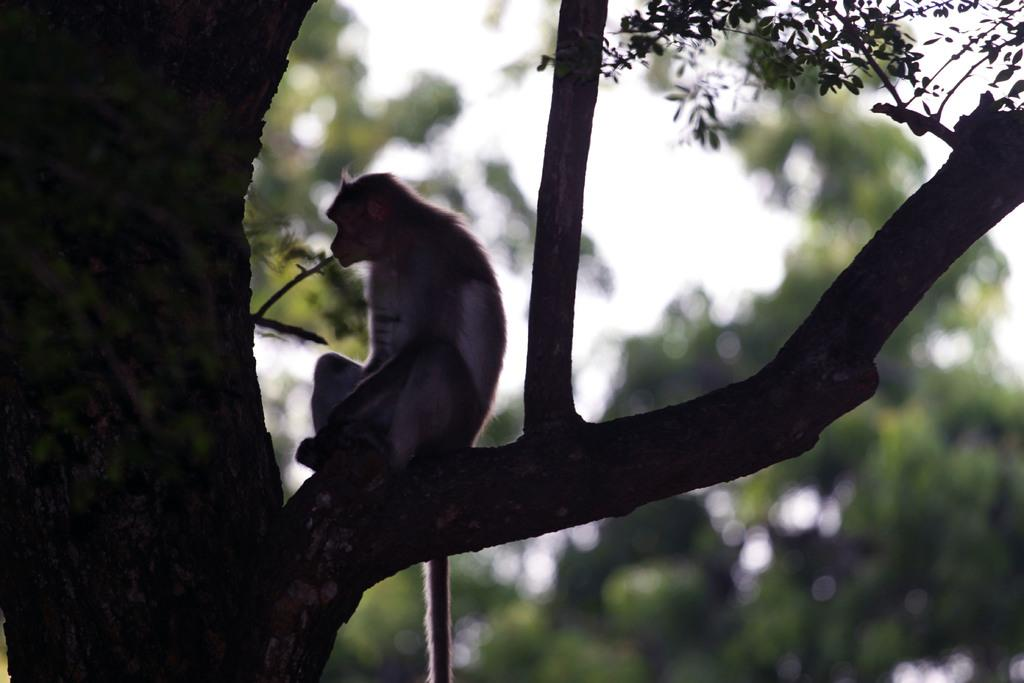What animal is present in the image? There is a monkey in the image. Where is the monkey located in the image? The monkey is sitting on a tree branch. What can be seen in the background of the image? The sky is visible in the image, and there are trees present. What type of environment might the image depict? The image may have been taken in a forest, given the presence of trees. What type of dress is the monkey wearing in the image? The monkey is not wearing a dress in the image, as monkeys do not wear clothing. 